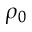Convert formula to latex. <formula><loc_0><loc_0><loc_500><loc_500>\rho _ { 0 }</formula> 